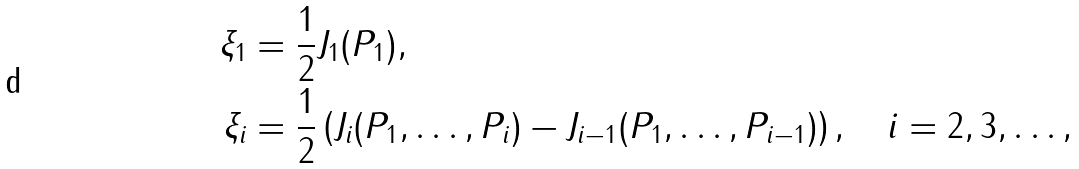Convert formula to latex. <formula><loc_0><loc_0><loc_500><loc_500>\xi _ { 1 } & = \frac { 1 } { 2 } J _ { 1 } ( P _ { 1 } ) , \\ \xi _ { i } & = \frac { 1 } { 2 } \left ( J _ { i } ( P _ { 1 } , \dots , P _ { i } ) - J _ { i - 1 } ( P _ { 1 } , \dots , P _ { i - 1 } ) \right ) , \quad i = 2 , 3 , \dots ,</formula> 